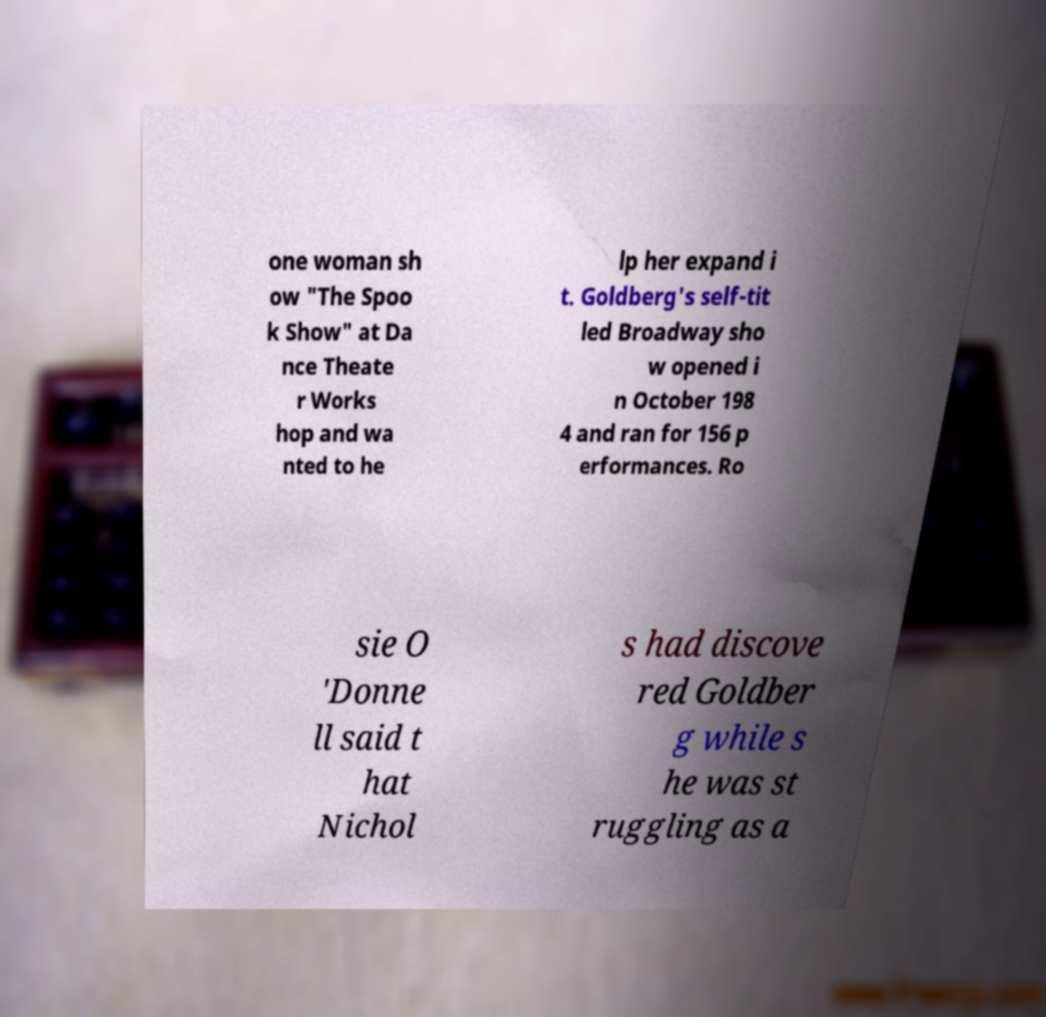Can you accurately transcribe the text from the provided image for me? one woman sh ow "The Spoo k Show" at Da nce Theate r Works hop and wa nted to he lp her expand i t. Goldberg's self-tit led Broadway sho w opened i n October 198 4 and ran for 156 p erformances. Ro sie O 'Donne ll said t hat Nichol s had discove red Goldber g while s he was st ruggling as a 